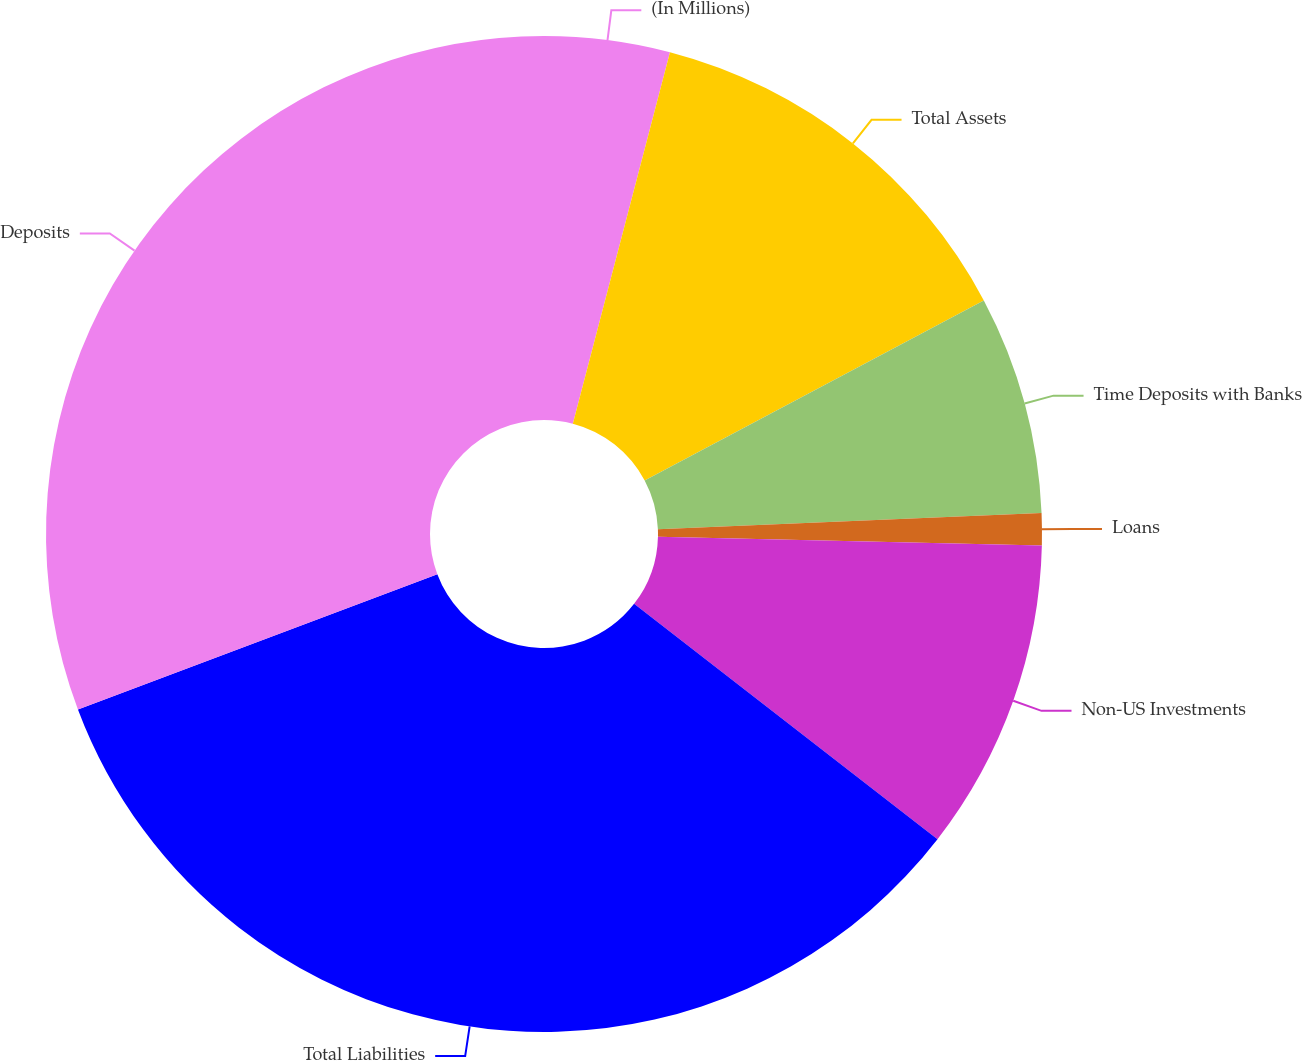<chart> <loc_0><loc_0><loc_500><loc_500><pie_chart><fcel>(In Millions)<fcel>Total Assets<fcel>Time Deposits with Banks<fcel>Loans<fcel>Non-US Investments<fcel>Total Liabilities<fcel>Deposits<nl><fcel>4.07%<fcel>13.16%<fcel>7.1%<fcel>1.04%<fcel>10.13%<fcel>33.77%<fcel>30.73%<nl></chart> 